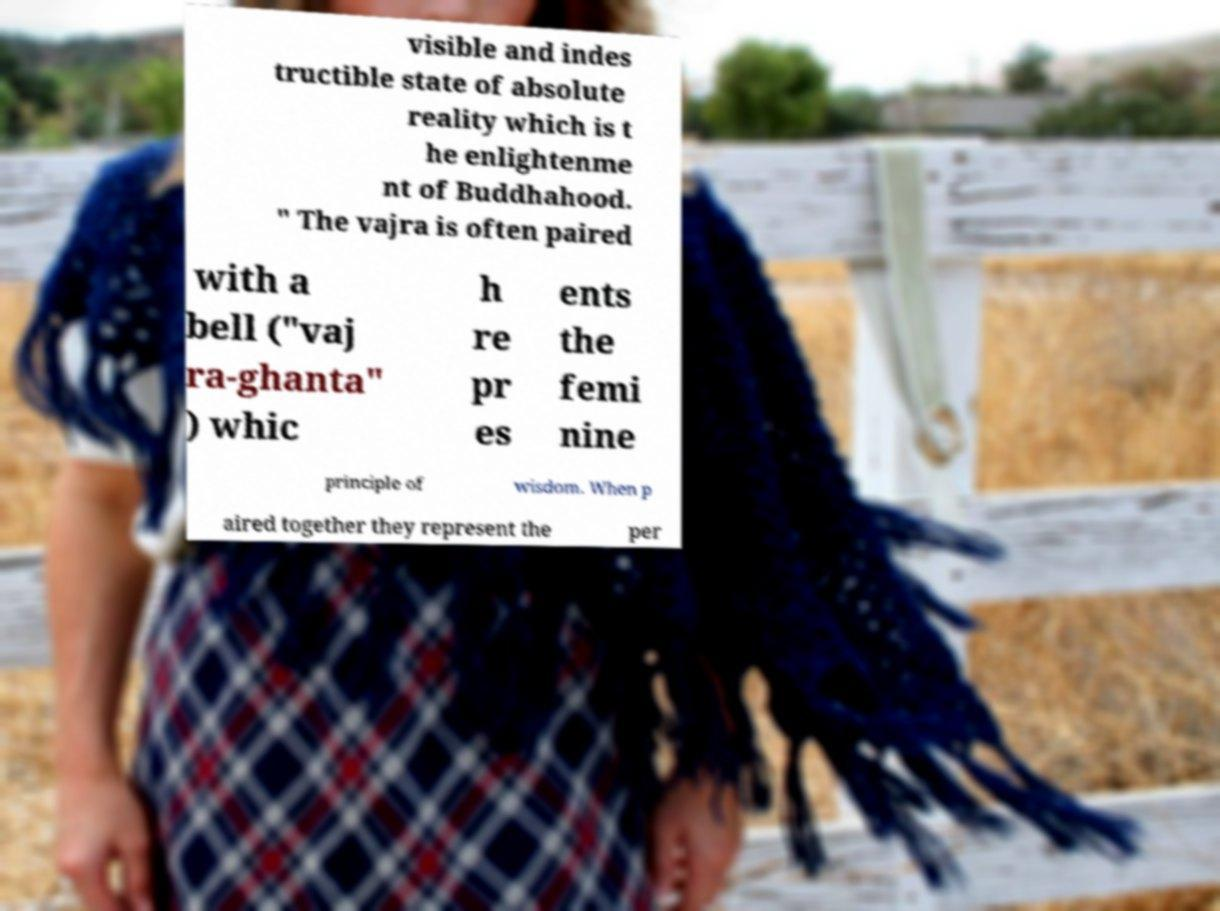Can you read and provide the text displayed in the image?This photo seems to have some interesting text. Can you extract and type it out for me? visible and indes tructible state of absolute reality which is t he enlightenme nt of Buddhahood. " The vajra is often paired with a bell ("vaj ra-ghanta" ) whic h re pr es ents the femi nine principle of wisdom. When p aired together they represent the per 